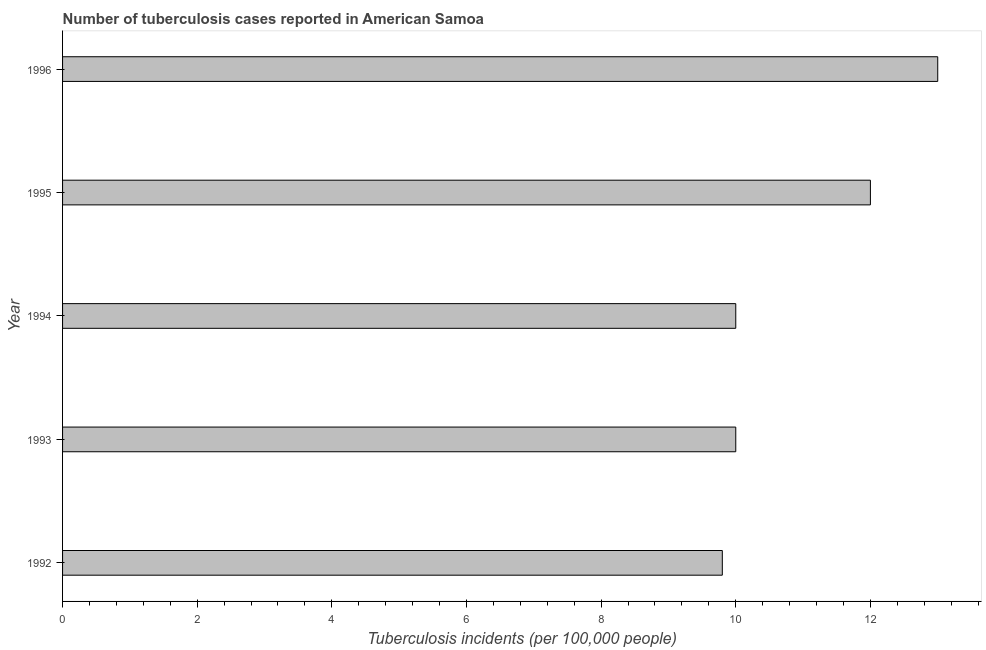What is the title of the graph?
Provide a succinct answer. Number of tuberculosis cases reported in American Samoa. What is the label or title of the X-axis?
Provide a succinct answer. Tuberculosis incidents (per 100,0 people). Across all years, what is the maximum number of tuberculosis incidents?
Your answer should be compact. 13. In which year was the number of tuberculosis incidents maximum?
Give a very brief answer. 1996. What is the sum of the number of tuberculosis incidents?
Ensure brevity in your answer.  54.8. What is the average number of tuberculosis incidents per year?
Your response must be concise. 10.96. Do a majority of the years between 1993 and 1996 (inclusive) have number of tuberculosis incidents greater than 7.2 ?
Ensure brevity in your answer.  Yes. What is the ratio of the number of tuberculosis incidents in 1994 to that in 1995?
Ensure brevity in your answer.  0.83. Is the number of tuberculosis incidents in 1993 less than that in 1995?
Provide a succinct answer. Yes. Is the difference between the number of tuberculosis incidents in 1994 and 1995 greater than the difference between any two years?
Your answer should be very brief. No. Is the sum of the number of tuberculosis incidents in 1992 and 1993 greater than the maximum number of tuberculosis incidents across all years?
Your answer should be compact. Yes. How many bars are there?
Make the answer very short. 5. Are all the bars in the graph horizontal?
Keep it short and to the point. Yes. What is the difference between two consecutive major ticks on the X-axis?
Provide a succinct answer. 2. Are the values on the major ticks of X-axis written in scientific E-notation?
Your answer should be very brief. No. What is the Tuberculosis incidents (per 100,000 people) of 1992?
Your answer should be compact. 9.8. What is the Tuberculosis incidents (per 100,000 people) in 1993?
Provide a short and direct response. 10. What is the difference between the Tuberculosis incidents (per 100,000 people) in 1992 and 1993?
Your response must be concise. -0.2. What is the difference between the Tuberculosis incidents (per 100,000 people) in 1992 and 1994?
Your answer should be compact. -0.2. What is the difference between the Tuberculosis incidents (per 100,000 people) in 1992 and 1996?
Your answer should be compact. -3.2. What is the difference between the Tuberculosis incidents (per 100,000 people) in 1993 and 1994?
Your response must be concise. 0. What is the difference between the Tuberculosis incidents (per 100,000 people) in 1993 and 1996?
Your answer should be compact. -3. What is the ratio of the Tuberculosis incidents (per 100,000 people) in 1992 to that in 1993?
Give a very brief answer. 0.98. What is the ratio of the Tuberculosis incidents (per 100,000 people) in 1992 to that in 1994?
Keep it short and to the point. 0.98. What is the ratio of the Tuberculosis incidents (per 100,000 people) in 1992 to that in 1995?
Give a very brief answer. 0.82. What is the ratio of the Tuberculosis incidents (per 100,000 people) in 1992 to that in 1996?
Ensure brevity in your answer.  0.75. What is the ratio of the Tuberculosis incidents (per 100,000 people) in 1993 to that in 1994?
Ensure brevity in your answer.  1. What is the ratio of the Tuberculosis incidents (per 100,000 people) in 1993 to that in 1995?
Provide a succinct answer. 0.83. What is the ratio of the Tuberculosis incidents (per 100,000 people) in 1993 to that in 1996?
Ensure brevity in your answer.  0.77. What is the ratio of the Tuberculosis incidents (per 100,000 people) in 1994 to that in 1995?
Offer a very short reply. 0.83. What is the ratio of the Tuberculosis incidents (per 100,000 people) in 1994 to that in 1996?
Provide a succinct answer. 0.77. What is the ratio of the Tuberculosis incidents (per 100,000 people) in 1995 to that in 1996?
Make the answer very short. 0.92. 